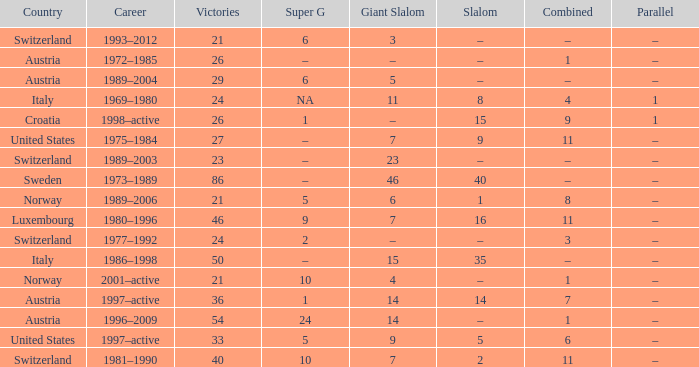What Giant Slalom has Victories larger than 27, a Slalom of –, and a Career of 1996–2009? 14.0. 